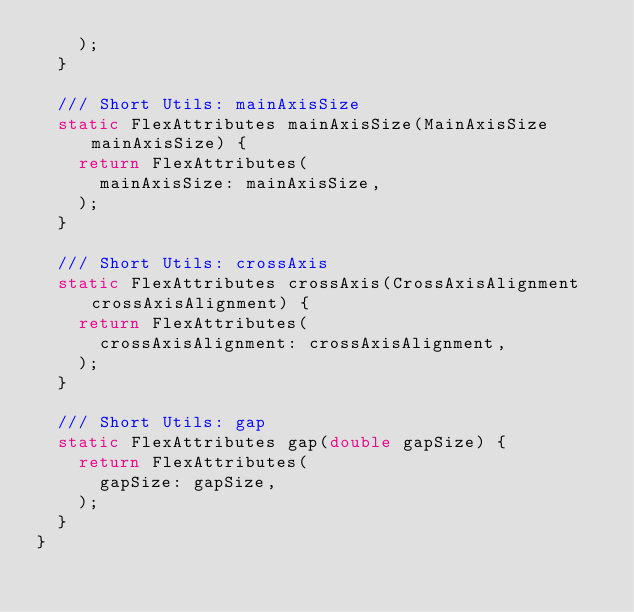<code> <loc_0><loc_0><loc_500><loc_500><_Dart_>    );
  }

  /// Short Utils: mainAxisSize
  static FlexAttributes mainAxisSize(MainAxisSize mainAxisSize) {
    return FlexAttributes(
      mainAxisSize: mainAxisSize,
    );
  }

  /// Short Utils: crossAxis
  static FlexAttributes crossAxis(CrossAxisAlignment crossAxisAlignment) {
    return FlexAttributes(
      crossAxisAlignment: crossAxisAlignment,
    );
  }

  /// Short Utils: gap
  static FlexAttributes gap(double gapSize) {
    return FlexAttributes(
      gapSize: gapSize,
    );
  }
}
</code> 